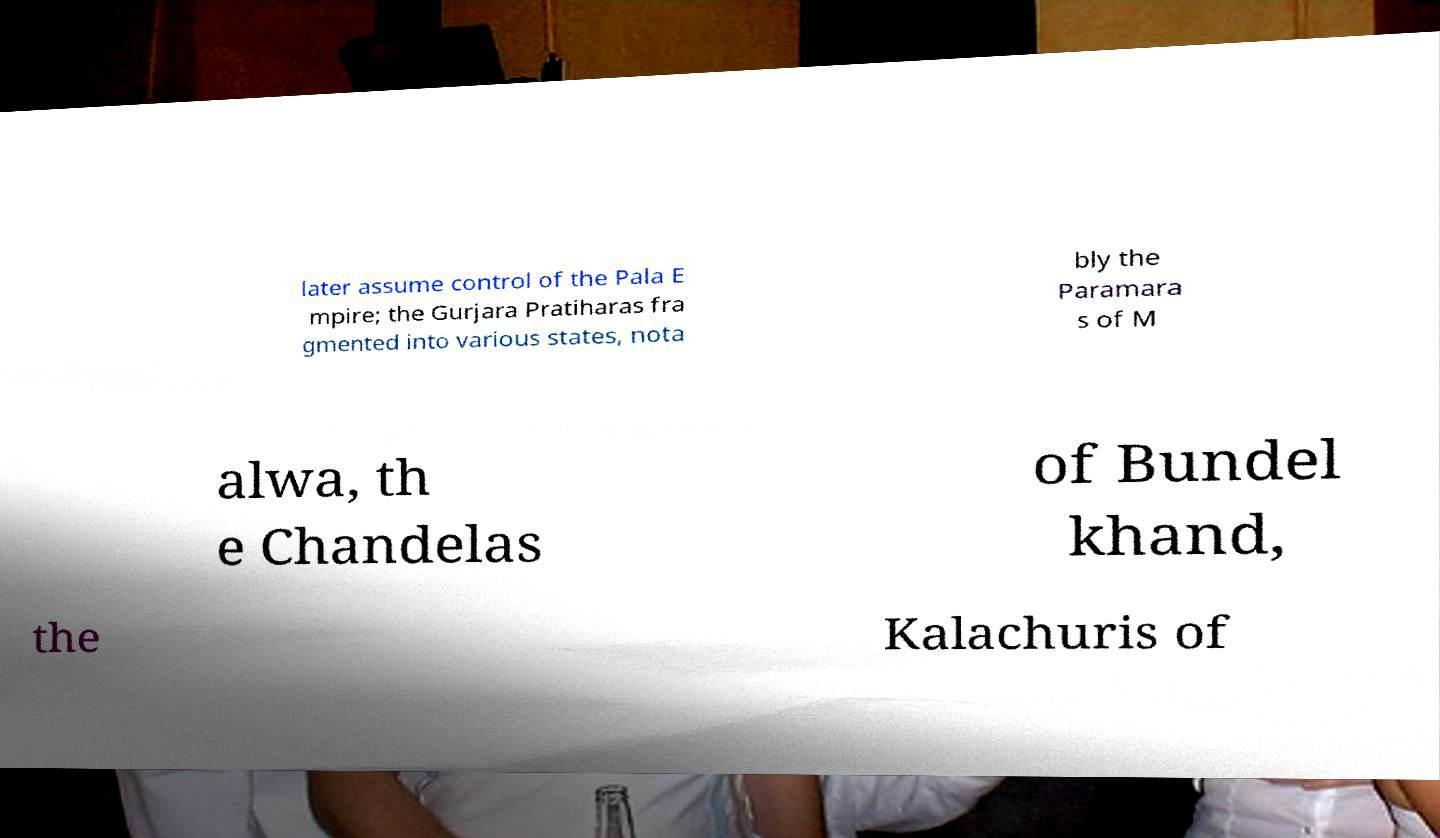Could you extract and type out the text from this image? later assume control of the Pala E mpire; the Gurjara Pratiharas fra gmented into various states, nota bly the Paramara s of M alwa, th e Chandelas of Bundel khand, the Kalachuris of 